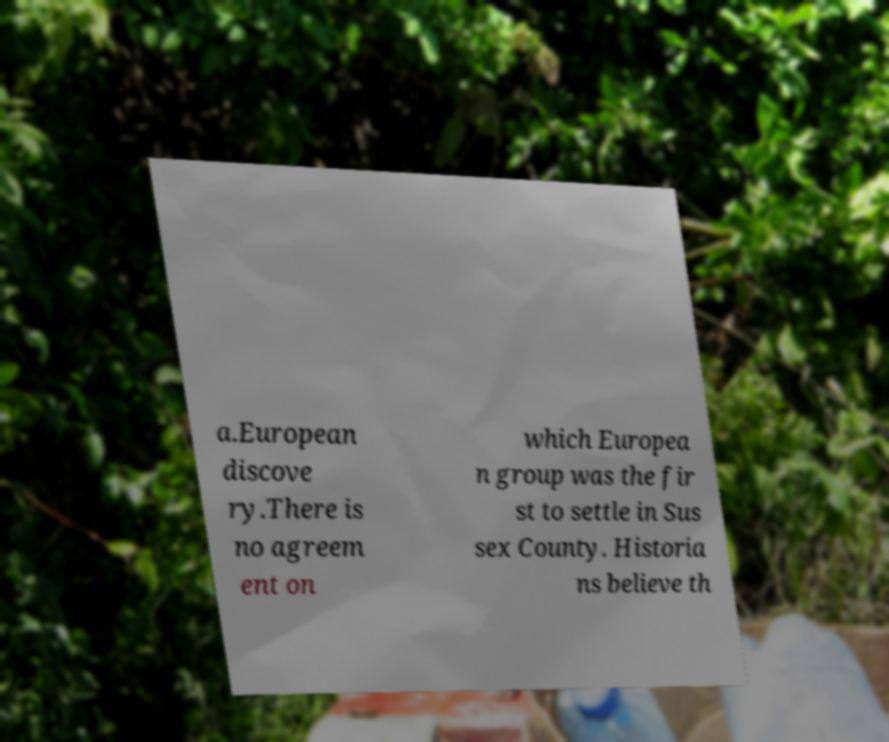Can you read and provide the text displayed in the image?This photo seems to have some interesting text. Can you extract and type it out for me? a.European discove ry.There is no agreem ent on which Europea n group was the fir st to settle in Sus sex County. Historia ns believe th 